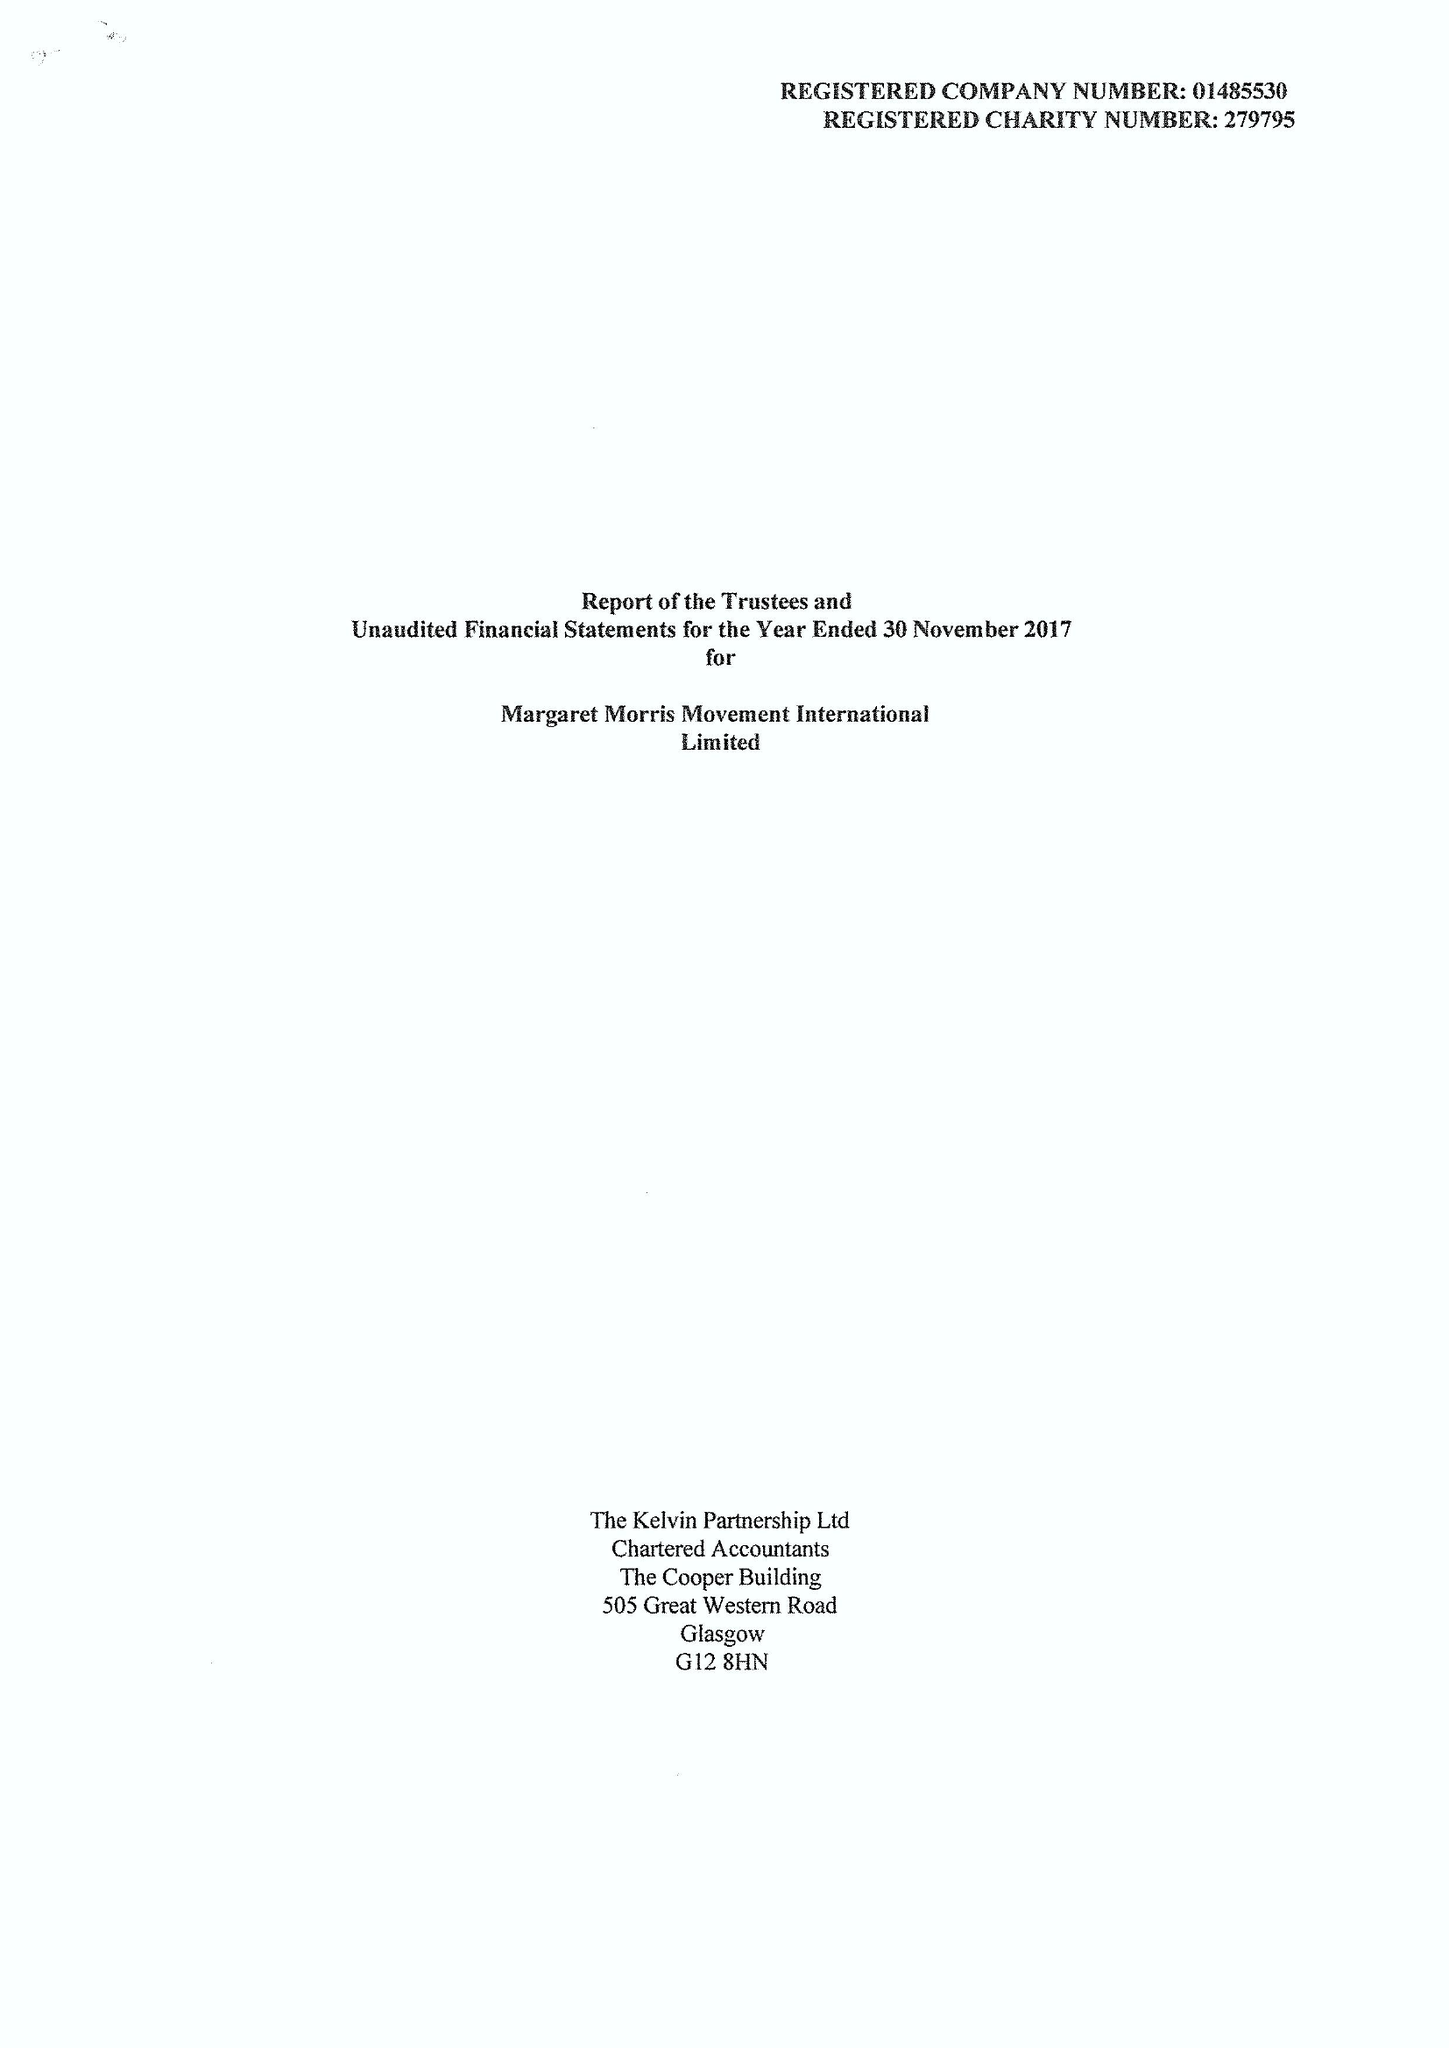What is the value for the spending_annually_in_british_pounds?
Answer the question using a single word or phrase. 58180.00 